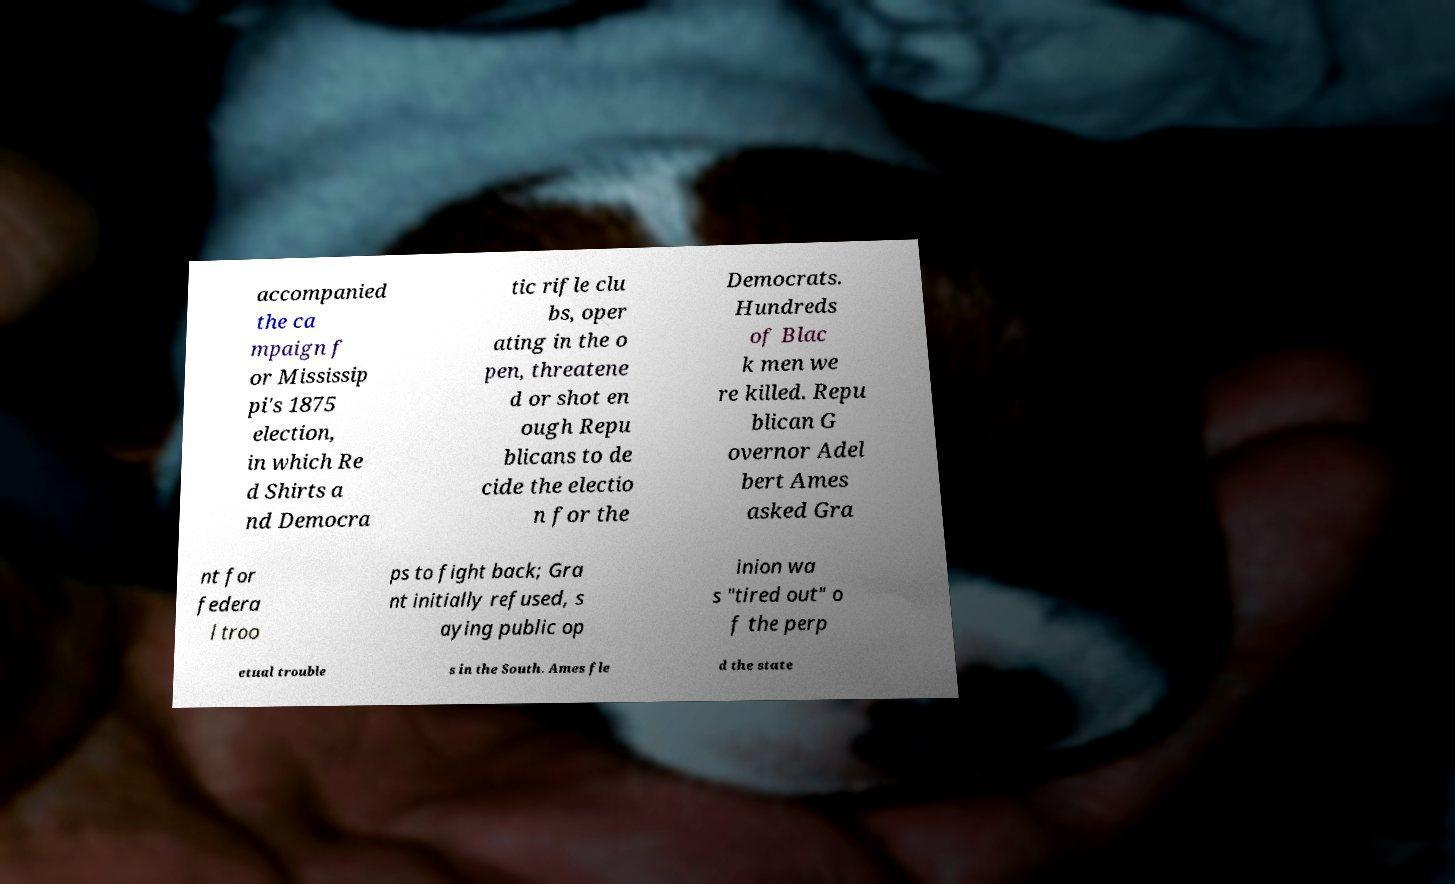Could you extract and type out the text from this image? accompanied the ca mpaign f or Mississip pi's 1875 election, in which Re d Shirts a nd Democra tic rifle clu bs, oper ating in the o pen, threatene d or shot en ough Repu blicans to de cide the electio n for the Democrats. Hundreds of Blac k men we re killed. Repu blican G overnor Adel bert Ames asked Gra nt for federa l troo ps to fight back; Gra nt initially refused, s aying public op inion wa s "tired out" o f the perp etual trouble s in the South. Ames fle d the state 